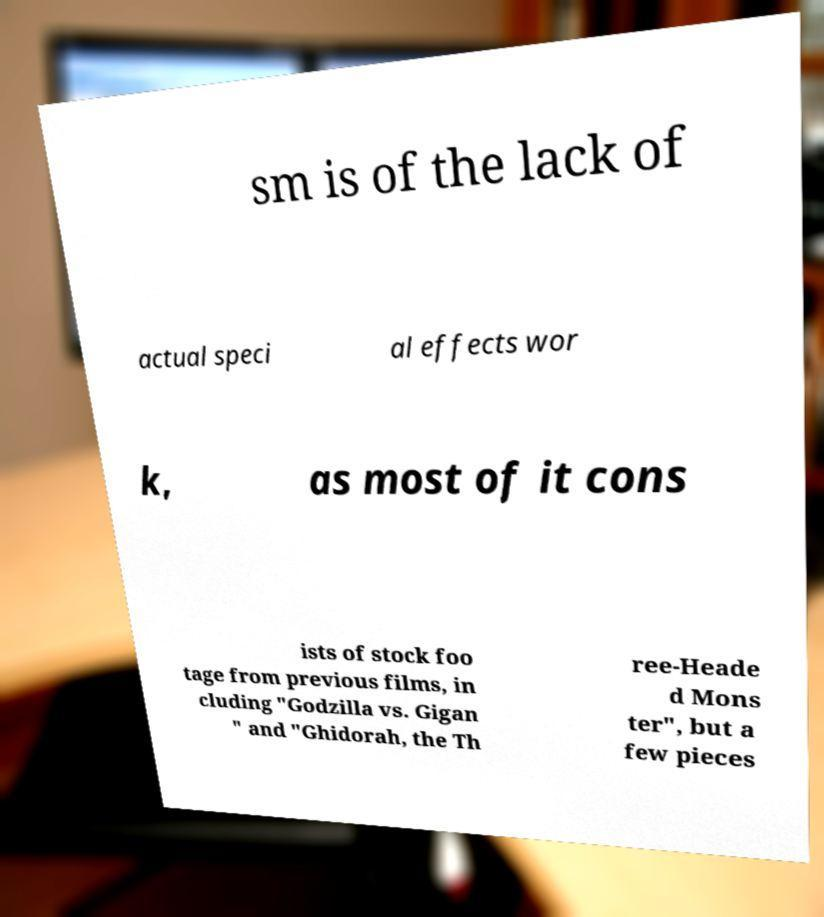For documentation purposes, I need the text within this image transcribed. Could you provide that? sm is of the lack of actual speci al effects wor k, as most of it cons ists of stock foo tage from previous films, in cluding "Godzilla vs. Gigan " and "Ghidorah, the Th ree-Heade d Mons ter", but a few pieces 